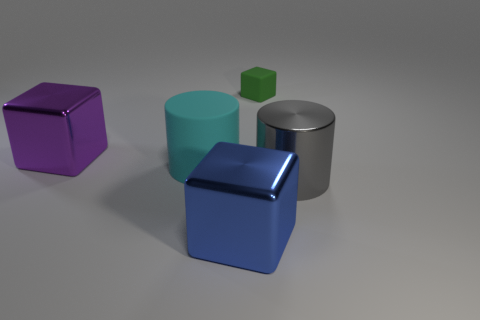Are there any other things that have the same size as the green matte thing?
Provide a short and direct response. No. How many objects are big metal cylinders in front of the large cyan rubber object or things that are right of the rubber cylinder?
Offer a terse response. 3. What is the color of the rubber thing that is behind the purple object?
Provide a succinct answer. Green. There is a large cylinder that is to the right of the green matte cube; is there a cyan rubber thing to the right of it?
Your answer should be compact. No. Is the number of small red matte cubes less than the number of large rubber things?
Offer a terse response. Yes. There is a large cube that is behind the shiny block that is to the right of the purple thing; what is it made of?
Keep it short and to the point. Metal. Do the gray metallic thing and the green thing have the same size?
Your answer should be compact. No. How many things are either big purple blocks or rubber cubes?
Keep it short and to the point. 2. How big is the cube that is both behind the big matte cylinder and to the right of the big purple shiny block?
Ensure brevity in your answer.  Small. Are there fewer small things behind the tiny rubber object than brown rubber cylinders?
Your answer should be very brief. No. 